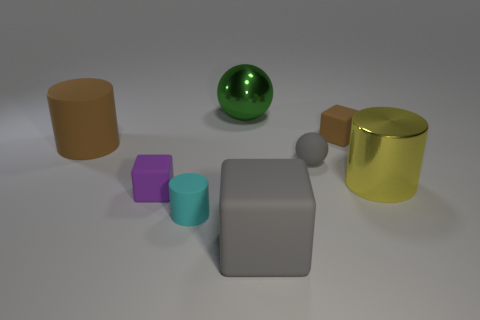Are there any other things that are the same color as the metal sphere?
Provide a succinct answer. No. What shape is the big object that is the same material as the big brown cylinder?
Give a very brief answer. Cube. Is the purple rubber thing the same size as the matte sphere?
Your answer should be very brief. Yes. Do the small block that is in front of the tiny brown cube and the large gray block have the same material?
Offer a terse response. Yes. There is a small block that is on the right side of the cylinder in front of the small purple thing; what number of big yellow metallic objects are in front of it?
Your response must be concise. 1. Does the brown object that is right of the cyan cylinder have the same shape as the large brown rubber object?
Make the answer very short. No. How many things are either big brown matte cylinders or gray objects on the right side of the big green object?
Offer a terse response. 3. Is the number of tiny brown things that are in front of the cyan cylinder greater than the number of big gray metallic cubes?
Your answer should be very brief. No. Are there an equal number of tiny gray spheres that are behind the tiny brown object and yellow things that are in front of the tiny rubber cylinder?
Make the answer very short. Yes. There is a big thing that is behind the big brown object; is there a large green metal thing that is behind it?
Offer a terse response. No. 